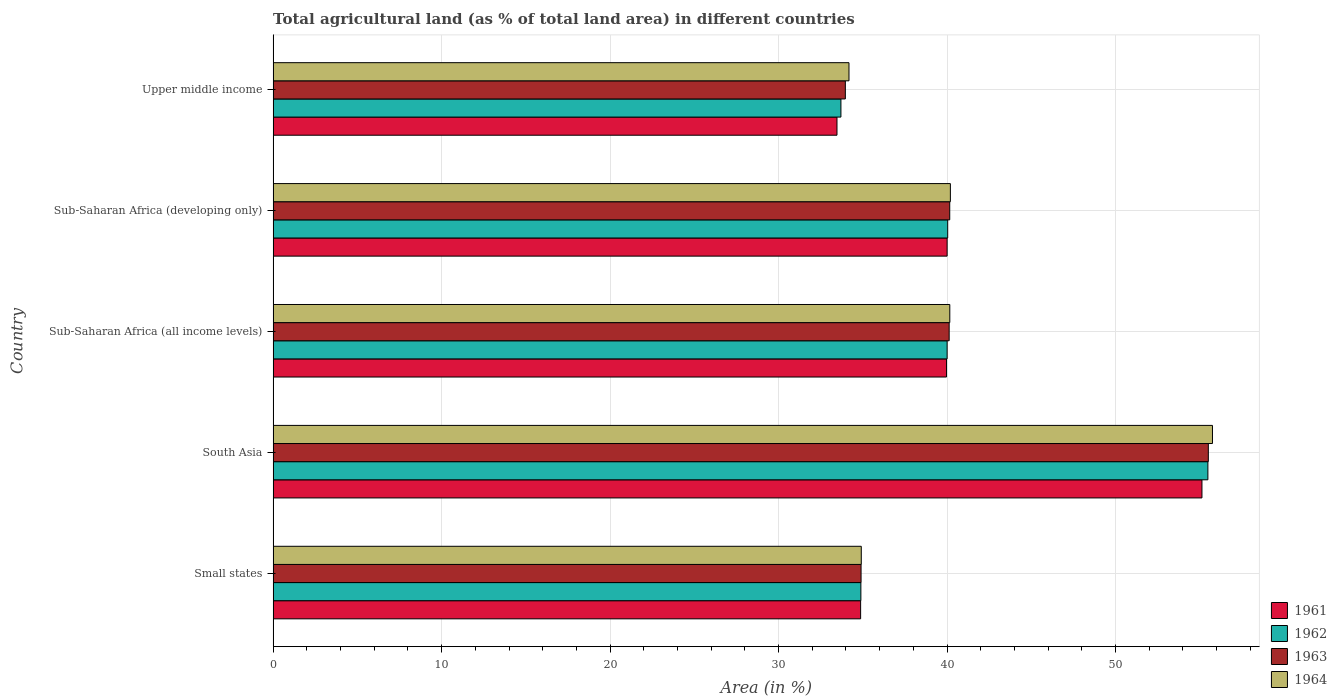Are the number of bars on each tick of the Y-axis equal?
Provide a short and direct response. Yes. How many bars are there on the 5th tick from the top?
Make the answer very short. 4. How many bars are there on the 5th tick from the bottom?
Offer a very short reply. 4. What is the label of the 4th group of bars from the top?
Provide a succinct answer. South Asia. What is the percentage of agricultural land in 1963 in Small states?
Provide a short and direct response. 34.9. Across all countries, what is the maximum percentage of agricultural land in 1962?
Make the answer very short. 55.48. Across all countries, what is the minimum percentage of agricultural land in 1961?
Provide a succinct answer. 33.47. In which country was the percentage of agricultural land in 1962 maximum?
Your answer should be compact. South Asia. In which country was the percentage of agricultural land in 1964 minimum?
Offer a very short reply. Upper middle income. What is the total percentage of agricultural land in 1964 in the graph?
Your answer should be very brief. 205.2. What is the difference between the percentage of agricultural land in 1961 in Small states and that in South Asia?
Provide a succinct answer. -20.26. What is the difference between the percentage of agricultural land in 1961 in Sub-Saharan Africa (developing only) and the percentage of agricultural land in 1963 in Small states?
Provide a succinct answer. 5.11. What is the average percentage of agricultural land in 1964 per country?
Your answer should be very brief. 41.04. What is the difference between the percentage of agricultural land in 1962 and percentage of agricultural land in 1964 in Upper middle income?
Your response must be concise. -0.48. What is the ratio of the percentage of agricultural land in 1962 in Sub-Saharan Africa (developing only) to that in Upper middle income?
Offer a very short reply. 1.19. Is the percentage of agricultural land in 1961 in Small states less than that in Upper middle income?
Give a very brief answer. No. Is the difference between the percentage of agricultural land in 1962 in Small states and South Asia greater than the difference between the percentage of agricultural land in 1964 in Small states and South Asia?
Your response must be concise. Yes. What is the difference between the highest and the second highest percentage of agricultural land in 1964?
Offer a terse response. 15.56. What is the difference between the highest and the lowest percentage of agricultural land in 1962?
Your answer should be compact. 21.78. In how many countries, is the percentage of agricultural land in 1962 greater than the average percentage of agricultural land in 1962 taken over all countries?
Make the answer very short. 1. What does the 1st bar from the top in Small states represents?
Give a very brief answer. 1964. What does the 3rd bar from the bottom in Sub-Saharan Africa (all income levels) represents?
Provide a short and direct response. 1963. Are all the bars in the graph horizontal?
Provide a succinct answer. Yes. Are the values on the major ticks of X-axis written in scientific E-notation?
Ensure brevity in your answer.  No. Does the graph contain any zero values?
Your response must be concise. No. Does the graph contain grids?
Keep it short and to the point. Yes. Where does the legend appear in the graph?
Offer a terse response. Bottom right. What is the title of the graph?
Ensure brevity in your answer.  Total agricultural land (as % of total land area) in different countries. Does "2006" appear as one of the legend labels in the graph?
Provide a succinct answer. No. What is the label or title of the X-axis?
Your response must be concise. Area (in %). What is the label or title of the Y-axis?
Your answer should be very brief. Country. What is the Area (in %) in 1961 in Small states?
Provide a succinct answer. 34.87. What is the Area (in %) in 1962 in Small states?
Ensure brevity in your answer.  34.88. What is the Area (in %) of 1963 in Small states?
Offer a terse response. 34.9. What is the Area (in %) in 1964 in Small states?
Your answer should be very brief. 34.91. What is the Area (in %) in 1961 in South Asia?
Offer a terse response. 55.13. What is the Area (in %) of 1962 in South Asia?
Give a very brief answer. 55.48. What is the Area (in %) of 1963 in South Asia?
Offer a terse response. 55.51. What is the Area (in %) of 1964 in South Asia?
Offer a very short reply. 55.75. What is the Area (in %) in 1961 in Sub-Saharan Africa (all income levels)?
Make the answer very short. 39.97. What is the Area (in %) of 1962 in Sub-Saharan Africa (all income levels)?
Make the answer very short. 40. What is the Area (in %) in 1963 in Sub-Saharan Africa (all income levels)?
Your answer should be compact. 40.12. What is the Area (in %) of 1964 in Sub-Saharan Africa (all income levels)?
Offer a very short reply. 40.16. What is the Area (in %) of 1961 in Sub-Saharan Africa (developing only)?
Make the answer very short. 40. What is the Area (in %) of 1962 in Sub-Saharan Africa (developing only)?
Make the answer very short. 40.04. What is the Area (in %) of 1963 in Sub-Saharan Africa (developing only)?
Make the answer very short. 40.16. What is the Area (in %) in 1964 in Sub-Saharan Africa (developing only)?
Your answer should be very brief. 40.2. What is the Area (in %) of 1961 in Upper middle income?
Your answer should be compact. 33.47. What is the Area (in %) in 1962 in Upper middle income?
Give a very brief answer. 33.7. What is the Area (in %) of 1963 in Upper middle income?
Provide a succinct answer. 33.96. What is the Area (in %) of 1964 in Upper middle income?
Ensure brevity in your answer.  34.18. Across all countries, what is the maximum Area (in %) of 1961?
Your response must be concise. 55.13. Across all countries, what is the maximum Area (in %) of 1962?
Offer a terse response. 55.48. Across all countries, what is the maximum Area (in %) in 1963?
Make the answer very short. 55.51. Across all countries, what is the maximum Area (in %) in 1964?
Offer a terse response. 55.75. Across all countries, what is the minimum Area (in %) in 1961?
Offer a very short reply. 33.47. Across all countries, what is the minimum Area (in %) in 1962?
Your answer should be compact. 33.7. Across all countries, what is the minimum Area (in %) of 1963?
Give a very brief answer. 33.96. Across all countries, what is the minimum Area (in %) of 1964?
Keep it short and to the point. 34.18. What is the total Area (in %) in 1961 in the graph?
Give a very brief answer. 203.44. What is the total Area (in %) of 1962 in the graph?
Your answer should be very brief. 204.11. What is the total Area (in %) in 1963 in the graph?
Make the answer very short. 204.65. What is the total Area (in %) of 1964 in the graph?
Offer a terse response. 205.2. What is the difference between the Area (in %) in 1961 in Small states and that in South Asia?
Keep it short and to the point. -20.26. What is the difference between the Area (in %) of 1962 in Small states and that in South Asia?
Offer a terse response. -20.6. What is the difference between the Area (in %) of 1963 in Small states and that in South Asia?
Give a very brief answer. -20.61. What is the difference between the Area (in %) in 1964 in Small states and that in South Asia?
Provide a short and direct response. -20.84. What is the difference between the Area (in %) of 1961 in Small states and that in Sub-Saharan Africa (all income levels)?
Make the answer very short. -5.1. What is the difference between the Area (in %) of 1962 in Small states and that in Sub-Saharan Africa (all income levels)?
Your response must be concise. -5.12. What is the difference between the Area (in %) of 1963 in Small states and that in Sub-Saharan Africa (all income levels)?
Your answer should be compact. -5.23. What is the difference between the Area (in %) in 1964 in Small states and that in Sub-Saharan Africa (all income levels)?
Offer a terse response. -5.25. What is the difference between the Area (in %) of 1961 in Small states and that in Sub-Saharan Africa (developing only)?
Provide a short and direct response. -5.13. What is the difference between the Area (in %) in 1962 in Small states and that in Sub-Saharan Africa (developing only)?
Keep it short and to the point. -5.15. What is the difference between the Area (in %) of 1963 in Small states and that in Sub-Saharan Africa (developing only)?
Offer a very short reply. -5.26. What is the difference between the Area (in %) in 1964 in Small states and that in Sub-Saharan Africa (developing only)?
Your answer should be compact. -5.29. What is the difference between the Area (in %) of 1961 in Small states and that in Upper middle income?
Ensure brevity in your answer.  1.4. What is the difference between the Area (in %) in 1962 in Small states and that in Upper middle income?
Keep it short and to the point. 1.18. What is the difference between the Area (in %) of 1963 in Small states and that in Upper middle income?
Ensure brevity in your answer.  0.93. What is the difference between the Area (in %) in 1964 in Small states and that in Upper middle income?
Your answer should be compact. 0.73. What is the difference between the Area (in %) of 1961 in South Asia and that in Sub-Saharan Africa (all income levels)?
Give a very brief answer. 15.16. What is the difference between the Area (in %) in 1962 in South Asia and that in Sub-Saharan Africa (all income levels)?
Your answer should be very brief. 15.48. What is the difference between the Area (in %) of 1963 in South Asia and that in Sub-Saharan Africa (all income levels)?
Keep it short and to the point. 15.38. What is the difference between the Area (in %) in 1964 in South Asia and that in Sub-Saharan Africa (all income levels)?
Give a very brief answer. 15.59. What is the difference between the Area (in %) of 1961 in South Asia and that in Sub-Saharan Africa (developing only)?
Give a very brief answer. 15.12. What is the difference between the Area (in %) in 1962 in South Asia and that in Sub-Saharan Africa (developing only)?
Provide a succinct answer. 15.44. What is the difference between the Area (in %) in 1963 in South Asia and that in Sub-Saharan Africa (developing only)?
Provide a short and direct response. 15.35. What is the difference between the Area (in %) of 1964 in South Asia and that in Sub-Saharan Africa (developing only)?
Your answer should be compact. 15.56. What is the difference between the Area (in %) of 1961 in South Asia and that in Upper middle income?
Your response must be concise. 21.66. What is the difference between the Area (in %) of 1962 in South Asia and that in Upper middle income?
Your answer should be very brief. 21.78. What is the difference between the Area (in %) in 1963 in South Asia and that in Upper middle income?
Your response must be concise. 21.54. What is the difference between the Area (in %) of 1964 in South Asia and that in Upper middle income?
Ensure brevity in your answer.  21.57. What is the difference between the Area (in %) of 1961 in Sub-Saharan Africa (all income levels) and that in Sub-Saharan Africa (developing only)?
Give a very brief answer. -0.03. What is the difference between the Area (in %) of 1962 in Sub-Saharan Africa (all income levels) and that in Sub-Saharan Africa (developing only)?
Give a very brief answer. -0.03. What is the difference between the Area (in %) in 1963 in Sub-Saharan Africa (all income levels) and that in Sub-Saharan Africa (developing only)?
Your answer should be very brief. -0.03. What is the difference between the Area (in %) in 1964 in Sub-Saharan Africa (all income levels) and that in Sub-Saharan Africa (developing only)?
Your answer should be very brief. -0.03. What is the difference between the Area (in %) of 1961 in Sub-Saharan Africa (all income levels) and that in Upper middle income?
Your response must be concise. 6.5. What is the difference between the Area (in %) of 1962 in Sub-Saharan Africa (all income levels) and that in Upper middle income?
Ensure brevity in your answer.  6.3. What is the difference between the Area (in %) of 1963 in Sub-Saharan Africa (all income levels) and that in Upper middle income?
Your response must be concise. 6.16. What is the difference between the Area (in %) in 1964 in Sub-Saharan Africa (all income levels) and that in Upper middle income?
Provide a succinct answer. 5.98. What is the difference between the Area (in %) in 1961 in Sub-Saharan Africa (developing only) and that in Upper middle income?
Your answer should be compact. 6.54. What is the difference between the Area (in %) of 1962 in Sub-Saharan Africa (developing only) and that in Upper middle income?
Offer a very short reply. 6.34. What is the difference between the Area (in %) in 1963 in Sub-Saharan Africa (developing only) and that in Upper middle income?
Your answer should be compact. 6.2. What is the difference between the Area (in %) in 1964 in Sub-Saharan Africa (developing only) and that in Upper middle income?
Ensure brevity in your answer.  6.02. What is the difference between the Area (in %) in 1961 in Small states and the Area (in %) in 1962 in South Asia?
Give a very brief answer. -20.61. What is the difference between the Area (in %) of 1961 in Small states and the Area (in %) of 1963 in South Asia?
Your answer should be very brief. -20.64. What is the difference between the Area (in %) of 1961 in Small states and the Area (in %) of 1964 in South Asia?
Provide a succinct answer. -20.88. What is the difference between the Area (in %) in 1962 in Small states and the Area (in %) in 1963 in South Asia?
Provide a succinct answer. -20.62. What is the difference between the Area (in %) of 1962 in Small states and the Area (in %) of 1964 in South Asia?
Offer a very short reply. -20.87. What is the difference between the Area (in %) of 1963 in Small states and the Area (in %) of 1964 in South Asia?
Your response must be concise. -20.86. What is the difference between the Area (in %) in 1961 in Small states and the Area (in %) in 1962 in Sub-Saharan Africa (all income levels)?
Provide a short and direct response. -5.13. What is the difference between the Area (in %) of 1961 in Small states and the Area (in %) of 1963 in Sub-Saharan Africa (all income levels)?
Provide a short and direct response. -5.25. What is the difference between the Area (in %) in 1961 in Small states and the Area (in %) in 1964 in Sub-Saharan Africa (all income levels)?
Your response must be concise. -5.29. What is the difference between the Area (in %) of 1962 in Small states and the Area (in %) of 1963 in Sub-Saharan Africa (all income levels)?
Ensure brevity in your answer.  -5.24. What is the difference between the Area (in %) of 1962 in Small states and the Area (in %) of 1964 in Sub-Saharan Africa (all income levels)?
Offer a very short reply. -5.28. What is the difference between the Area (in %) of 1963 in Small states and the Area (in %) of 1964 in Sub-Saharan Africa (all income levels)?
Give a very brief answer. -5.27. What is the difference between the Area (in %) in 1961 in Small states and the Area (in %) in 1962 in Sub-Saharan Africa (developing only)?
Offer a terse response. -5.17. What is the difference between the Area (in %) in 1961 in Small states and the Area (in %) in 1963 in Sub-Saharan Africa (developing only)?
Provide a succinct answer. -5.29. What is the difference between the Area (in %) of 1961 in Small states and the Area (in %) of 1964 in Sub-Saharan Africa (developing only)?
Provide a succinct answer. -5.33. What is the difference between the Area (in %) of 1962 in Small states and the Area (in %) of 1963 in Sub-Saharan Africa (developing only)?
Make the answer very short. -5.27. What is the difference between the Area (in %) of 1962 in Small states and the Area (in %) of 1964 in Sub-Saharan Africa (developing only)?
Provide a short and direct response. -5.31. What is the difference between the Area (in %) in 1963 in Small states and the Area (in %) in 1964 in Sub-Saharan Africa (developing only)?
Make the answer very short. -5.3. What is the difference between the Area (in %) of 1961 in Small states and the Area (in %) of 1962 in Upper middle income?
Ensure brevity in your answer.  1.17. What is the difference between the Area (in %) of 1961 in Small states and the Area (in %) of 1963 in Upper middle income?
Offer a very short reply. 0.91. What is the difference between the Area (in %) of 1961 in Small states and the Area (in %) of 1964 in Upper middle income?
Your response must be concise. 0.69. What is the difference between the Area (in %) of 1962 in Small states and the Area (in %) of 1963 in Upper middle income?
Keep it short and to the point. 0.92. What is the difference between the Area (in %) in 1962 in Small states and the Area (in %) in 1964 in Upper middle income?
Give a very brief answer. 0.71. What is the difference between the Area (in %) of 1963 in Small states and the Area (in %) of 1964 in Upper middle income?
Provide a succinct answer. 0.72. What is the difference between the Area (in %) of 1961 in South Asia and the Area (in %) of 1962 in Sub-Saharan Africa (all income levels)?
Provide a succinct answer. 15.12. What is the difference between the Area (in %) of 1961 in South Asia and the Area (in %) of 1963 in Sub-Saharan Africa (all income levels)?
Give a very brief answer. 15. What is the difference between the Area (in %) of 1961 in South Asia and the Area (in %) of 1964 in Sub-Saharan Africa (all income levels)?
Provide a short and direct response. 14.97. What is the difference between the Area (in %) of 1962 in South Asia and the Area (in %) of 1963 in Sub-Saharan Africa (all income levels)?
Ensure brevity in your answer.  15.36. What is the difference between the Area (in %) in 1962 in South Asia and the Area (in %) in 1964 in Sub-Saharan Africa (all income levels)?
Provide a short and direct response. 15.32. What is the difference between the Area (in %) of 1963 in South Asia and the Area (in %) of 1964 in Sub-Saharan Africa (all income levels)?
Offer a very short reply. 15.35. What is the difference between the Area (in %) of 1961 in South Asia and the Area (in %) of 1962 in Sub-Saharan Africa (developing only)?
Make the answer very short. 15.09. What is the difference between the Area (in %) in 1961 in South Asia and the Area (in %) in 1963 in Sub-Saharan Africa (developing only)?
Your answer should be very brief. 14.97. What is the difference between the Area (in %) in 1961 in South Asia and the Area (in %) in 1964 in Sub-Saharan Africa (developing only)?
Keep it short and to the point. 14.93. What is the difference between the Area (in %) of 1962 in South Asia and the Area (in %) of 1963 in Sub-Saharan Africa (developing only)?
Make the answer very short. 15.32. What is the difference between the Area (in %) of 1962 in South Asia and the Area (in %) of 1964 in Sub-Saharan Africa (developing only)?
Provide a short and direct response. 15.28. What is the difference between the Area (in %) in 1963 in South Asia and the Area (in %) in 1964 in Sub-Saharan Africa (developing only)?
Offer a terse response. 15.31. What is the difference between the Area (in %) of 1961 in South Asia and the Area (in %) of 1962 in Upper middle income?
Offer a very short reply. 21.43. What is the difference between the Area (in %) in 1961 in South Asia and the Area (in %) in 1963 in Upper middle income?
Make the answer very short. 21.17. What is the difference between the Area (in %) in 1961 in South Asia and the Area (in %) in 1964 in Upper middle income?
Your answer should be compact. 20.95. What is the difference between the Area (in %) in 1962 in South Asia and the Area (in %) in 1963 in Upper middle income?
Provide a short and direct response. 21.52. What is the difference between the Area (in %) of 1962 in South Asia and the Area (in %) of 1964 in Upper middle income?
Keep it short and to the point. 21.3. What is the difference between the Area (in %) in 1963 in South Asia and the Area (in %) in 1964 in Upper middle income?
Provide a succinct answer. 21.33. What is the difference between the Area (in %) of 1961 in Sub-Saharan Africa (all income levels) and the Area (in %) of 1962 in Sub-Saharan Africa (developing only)?
Keep it short and to the point. -0.07. What is the difference between the Area (in %) of 1961 in Sub-Saharan Africa (all income levels) and the Area (in %) of 1963 in Sub-Saharan Africa (developing only)?
Your answer should be very brief. -0.19. What is the difference between the Area (in %) of 1961 in Sub-Saharan Africa (all income levels) and the Area (in %) of 1964 in Sub-Saharan Africa (developing only)?
Keep it short and to the point. -0.23. What is the difference between the Area (in %) in 1962 in Sub-Saharan Africa (all income levels) and the Area (in %) in 1963 in Sub-Saharan Africa (developing only)?
Ensure brevity in your answer.  -0.15. What is the difference between the Area (in %) of 1962 in Sub-Saharan Africa (all income levels) and the Area (in %) of 1964 in Sub-Saharan Africa (developing only)?
Your answer should be very brief. -0.19. What is the difference between the Area (in %) in 1963 in Sub-Saharan Africa (all income levels) and the Area (in %) in 1964 in Sub-Saharan Africa (developing only)?
Offer a very short reply. -0.07. What is the difference between the Area (in %) in 1961 in Sub-Saharan Africa (all income levels) and the Area (in %) in 1962 in Upper middle income?
Provide a succinct answer. 6.27. What is the difference between the Area (in %) of 1961 in Sub-Saharan Africa (all income levels) and the Area (in %) of 1963 in Upper middle income?
Make the answer very short. 6.01. What is the difference between the Area (in %) in 1961 in Sub-Saharan Africa (all income levels) and the Area (in %) in 1964 in Upper middle income?
Make the answer very short. 5.79. What is the difference between the Area (in %) in 1962 in Sub-Saharan Africa (all income levels) and the Area (in %) in 1963 in Upper middle income?
Your answer should be very brief. 6.04. What is the difference between the Area (in %) of 1962 in Sub-Saharan Africa (all income levels) and the Area (in %) of 1964 in Upper middle income?
Your answer should be very brief. 5.82. What is the difference between the Area (in %) of 1963 in Sub-Saharan Africa (all income levels) and the Area (in %) of 1964 in Upper middle income?
Offer a terse response. 5.95. What is the difference between the Area (in %) of 1961 in Sub-Saharan Africa (developing only) and the Area (in %) of 1962 in Upper middle income?
Provide a succinct answer. 6.3. What is the difference between the Area (in %) in 1961 in Sub-Saharan Africa (developing only) and the Area (in %) in 1963 in Upper middle income?
Give a very brief answer. 6.04. What is the difference between the Area (in %) of 1961 in Sub-Saharan Africa (developing only) and the Area (in %) of 1964 in Upper middle income?
Offer a terse response. 5.82. What is the difference between the Area (in %) of 1962 in Sub-Saharan Africa (developing only) and the Area (in %) of 1963 in Upper middle income?
Your answer should be compact. 6.08. What is the difference between the Area (in %) in 1962 in Sub-Saharan Africa (developing only) and the Area (in %) in 1964 in Upper middle income?
Your response must be concise. 5.86. What is the difference between the Area (in %) of 1963 in Sub-Saharan Africa (developing only) and the Area (in %) of 1964 in Upper middle income?
Make the answer very short. 5.98. What is the average Area (in %) in 1961 per country?
Your answer should be very brief. 40.69. What is the average Area (in %) of 1962 per country?
Offer a very short reply. 40.82. What is the average Area (in %) in 1963 per country?
Provide a succinct answer. 40.93. What is the average Area (in %) of 1964 per country?
Your response must be concise. 41.04. What is the difference between the Area (in %) of 1961 and Area (in %) of 1962 in Small states?
Provide a succinct answer. -0.01. What is the difference between the Area (in %) in 1961 and Area (in %) in 1963 in Small states?
Your answer should be very brief. -0.03. What is the difference between the Area (in %) in 1961 and Area (in %) in 1964 in Small states?
Provide a succinct answer. -0.04. What is the difference between the Area (in %) of 1962 and Area (in %) of 1963 in Small states?
Provide a short and direct response. -0.01. What is the difference between the Area (in %) of 1962 and Area (in %) of 1964 in Small states?
Make the answer very short. -0.02. What is the difference between the Area (in %) of 1963 and Area (in %) of 1964 in Small states?
Your response must be concise. -0.01. What is the difference between the Area (in %) in 1961 and Area (in %) in 1962 in South Asia?
Ensure brevity in your answer.  -0.35. What is the difference between the Area (in %) in 1961 and Area (in %) in 1963 in South Asia?
Keep it short and to the point. -0.38. What is the difference between the Area (in %) of 1961 and Area (in %) of 1964 in South Asia?
Your answer should be very brief. -0.62. What is the difference between the Area (in %) of 1962 and Area (in %) of 1963 in South Asia?
Make the answer very short. -0.03. What is the difference between the Area (in %) in 1962 and Area (in %) in 1964 in South Asia?
Your answer should be compact. -0.27. What is the difference between the Area (in %) in 1963 and Area (in %) in 1964 in South Asia?
Ensure brevity in your answer.  -0.24. What is the difference between the Area (in %) in 1961 and Area (in %) in 1962 in Sub-Saharan Africa (all income levels)?
Provide a short and direct response. -0.04. What is the difference between the Area (in %) of 1961 and Area (in %) of 1963 in Sub-Saharan Africa (all income levels)?
Provide a short and direct response. -0.16. What is the difference between the Area (in %) of 1961 and Area (in %) of 1964 in Sub-Saharan Africa (all income levels)?
Provide a succinct answer. -0.19. What is the difference between the Area (in %) in 1962 and Area (in %) in 1963 in Sub-Saharan Africa (all income levels)?
Your answer should be compact. -0.12. What is the difference between the Area (in %) of 1962 and Area (in %) of 1964 in Sub-Saharan Africa (all income levels)?
Offer a terse response. -0.16. What is the difference between the Area (in %) in 1963 and Area (in %) in 1964 in Sub-Saharan Africa (all income levels)?
Offer a very short reply. -0.04. What is the difference between the Area (in %) in 1961 and Area (in %) in 1962 in Sub-Saharan Africa (developing only)?
Your response must be concise. -0.03. What is the difference between the Area (in %) in 1961 and Area (in %) in 1963 in Sub-Saharan Africa (developing only)?
Give a very brief answer. -0.16. What is the difference between the Area (in %) of 1961 and Area (in %) of 1964 in Sub-Saharan Africa (developing only)?
Give a very brief answer. -0.19. What is the difference between the Area (in %) in 1962 and Area (in %) in 1963 in Sub-Saharan Africa (developing only)?
Provide a succinct answer. -0.12. What is the difference between the Area (in %) in 1962 and Area (in %) in 1964 in Sub-Saharan Africa (developing only)?
Keep it short and to the point. -0.16. What is the difference between the Area (in %) of 1963 and Area (in %) of 1964 in Sub-Saharan Africa (developing only)?
Keep it short and to the point. -0.04. What is the difference between the Area (in %) in 1961 and Area (in %) in 1962 in Upper middle income?
Give a very brief answer. -0.23. What is the difference between the Area (in %) of 1961 and Area (in %) of 1963 in Upper middle income?
Your answer should be compact. -0.5. What is the difference between the Area (in %) in 1961 and Area (in %) in 1964 in Upper middle income?
Your response must be concise. -0.71. What is the difference between the Area (in %) of 1962 and Area (in %) of 1963 in Upper middle income?
Provide a short and direct response. -0.26. What is the difference between the Area (in %) in 1962 and Area (in %) in 1964 in Upper middle income?
Your answer should be very brief. -0.48. What is the difference between the Area (in %) in 1963 and Area (in %) in 1964 in Upper middle income?
Ensure brevity in your answer.  -0.22. What is the ratio of the Area (in %) in 1961 in Small states to that in South Asia?
Provide a succinct answer. 0.63. What is the ratio of the Area (in %) of 1962 in Small states to that in South Asia?
Offer a terse response. 0.63. What is the ratio of the Area (in %) of 1963 in Small states to that in South Asia?
Provide a succinct answer. 0.63. What is the ratio of the Area (in %) in 1964 in Small states to that in South Asia?
Your response must be concise. 0.63. What is the ratio of the Area (in %) of 1961 in Small states to that in Sub-Saharan Africa (all income levels)?
Your answer should be very brief. 0.87. What is the ratio of the Area (in %) in 1962 in Small states to that in Sub-Saharan Africa (all income levels)?
Your response must be concise. 0.87. What is the ratio of the Area (in %) in 1963 in Small states to that in Sub-Saharan Africa (all income levels)?
Your answer should be compact. 0.87. What is the ratio of the Area (in %) in 1964 in Small states to that in Sub-Saharan Africa (all income levels)?
Make the answer very short. 0.87. What is the ratio of the Area (in %) of 1961 in Small states to that in Sub-Saharan Africa (developing only)?
Your answer should be compact. 0.87. What is the ratio of the Area (in %) of 1962 in Small states to that in Sub-Saharan Africa (developing only)?
Provide a succinct answer. 0.87. What is the ratio of the Area (in %) of 1963 in Small states to that in Sub-Saharan Africa (developing only)?
Provide a short and direct response. 0.87. What is the ratio of the Area (in %) of 1964 in Small states to that in Sub-Saharan Africa (developing only)?
Your response must be concise. 0.87. What is the ratio of the Area (in %) of 1961 in Small states to that in Upper middle income?
Give a very brief answer. 1.04. What is the ratio of the Area (in %) in 1962 in Small states to that in Upper middle income?
Your answer should be compact. 1.04. What is the ratio of the Area (in %) in 1963 in Small states to that in Upper middle income?
Provide a succinct answer. 1.03. What is the ratio of the Area (in %) in 1964 in Small states to that in Upper middle income?
Keep it short and to the point. 1.02. What is the ratio of the Area (in %) of 1961 in South Asia to that in Sub-Saharan Africa (all income levels)?
Your response must be concise. 1.38. What is the ratio of the Area (in %) in 1962 in South Asia to that in Sub-Saharan Africa (all income levels)?
Give a very brief answer. 1.39. What is the ratio of the Area (in %) of 1963 in South Asia to that in Sub-Saharan Africa (all income levels)?
Ensure brevity in your answer.  1.38. What is the ratio of the Area (in %) of 1964 in South Asia to that in Sub-Saharan Africa (all income levels)?
Your answer should be compact. 1.39. What is the ratio of the Area (in %) of 1961 in South Asia to that in Sub-Saharan Africa (developing only)?
Your response must be concise. 1.38. What is the ratio of the Area (in %) in 1962 in South Asia to that in Sub-Saharan Africa (developing only)?
Offer a very short reply. 1.39. What is the ratio of the Area (in %) in 1963 in South Asia to that in Sub-Saharan Africa (developing only)?
Your answer should be compact. 1.38. What is the ratio of the Area (in %) of 1964 in South Asia to that in Sub-Saharan Africa (developing only)?
Offer a terse response. 1.39. What is the ratio of the Area (in %) of 1961 in South Asia to that in Upper middle income?
Keep it short and to the point. 1.65. What is the ratio of the Area (in %) in 1962 in South Asia to that in Upper middle income?
Keep it short and to the point. 1.65. What is the ratio of the Area (in %) in 1963 in South Asia to that in Upper middle income?
Give a very brief answer. 1.63. What is the ratio of the Area (in %) in 1964 in South Asia to that in Upper middle income?
Your response must be concise. 1.63. What is the ratio of the Area (in %) of 1962 in Sub-Saharan Africa (all income levels) to that in Sub-Saharan Africa (developing only)?
Provide a succinct answer. 1. What is the ratio of the Area (in %) in 1963 in Sub-Saharan Africa (all income levels) to that in Sub-Saharan Africa (developing only)?
Offer a very short reply. 1. What is the ratio of the Area (in %) of 1964 in Sub-Saharan Africa (all income levels) to that in Sub-Saharan Africa (developing only)?
Provide a succinct answer. 1. What is the ratio of the Area (in %) in 1961 in Sub-Saharan Africa (all income levels) to that in Upper middle income?
Your answer should be compact. 1.19. What is the ratio of the Area (in %) in 1962 in Sub-Saharan Africa (all income levels) to that in Upper middle income?
Your response must be concise. 1.19. What is the ratio of the Area (in %) of 1963 in Sub-Saharan Africa (all income levels) to that in Upper middle income?
Offer a terse response. 1.18. What is the ratio of the Area (in %) of 1964 in Sub-Saharan Africa (all income levels) to that in Upper middle income?
Your response must be concise. 1.18. What is the ratio of the Area (in %) in 1961 in Sub-Saharan Africa (developing only) to that in Upper middle income?
Offer a terse response. 1.2. What is the ratio of the Area (in %) in 1962 in Sub-Saharan Africa (developing only) to that in Upper middle income?
Make the answer very short. 1.19. What is the ratio of the Area (in %) of 1963 in Sub-Saharan Africa (developing only) to that in Upper middle income?
Your answer should be very brief. 1.18. What is the ratio of the Area (in %) in 1964 in Sub-Saharan Africa (developing only) to that in Upper middle income?
Ensure brevity in your answer.  1.18. What is the difference between the highest and the second highest Area (in %) in 1961?
Keep it short and to the point. 15.12. What is the difference between the highest and the second highest Area (in %) of 1962?
Your response must be concise. 15.44. What is the difference between the highest and the second highest Area (in %) of 1963?
Give a very brief answer. 15.35. What is the difference between the highest and the second highest Area (in %) in 1964?
Make the answer very short. 15.56. What is the difference between the highest and the lowest Area (in %) of 1961?
Your answer should be compact. 21.66. What is the difference between the highest and the lowest Area (in %) in 1962?
Ensure brevity in your answer.  21.78. What is the difference between the highest and the lowest Area (in %) in 1963?
Your answer should be compact. 21.54. What is the difference between the highest and the lowest Area (in %) of 1964?
Provide a short and direct response. 21.57. 